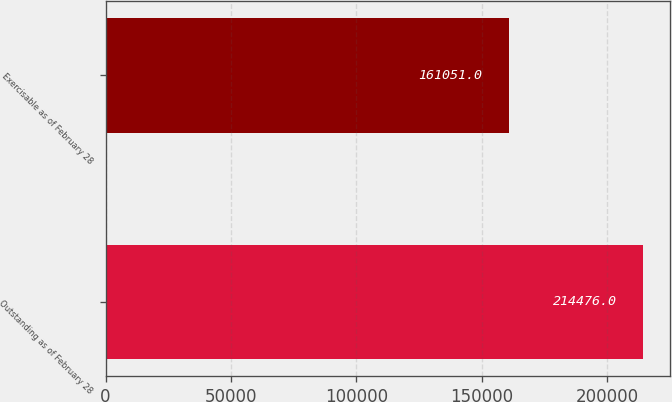<chart> <loc_0><loc_0><loc_500><loc_500><bar_chart><fcel>Outstanding as of February 28<fcel>Exercisable as of February 28<nl><fcel>214476<fcel>161051<nl></chart> 